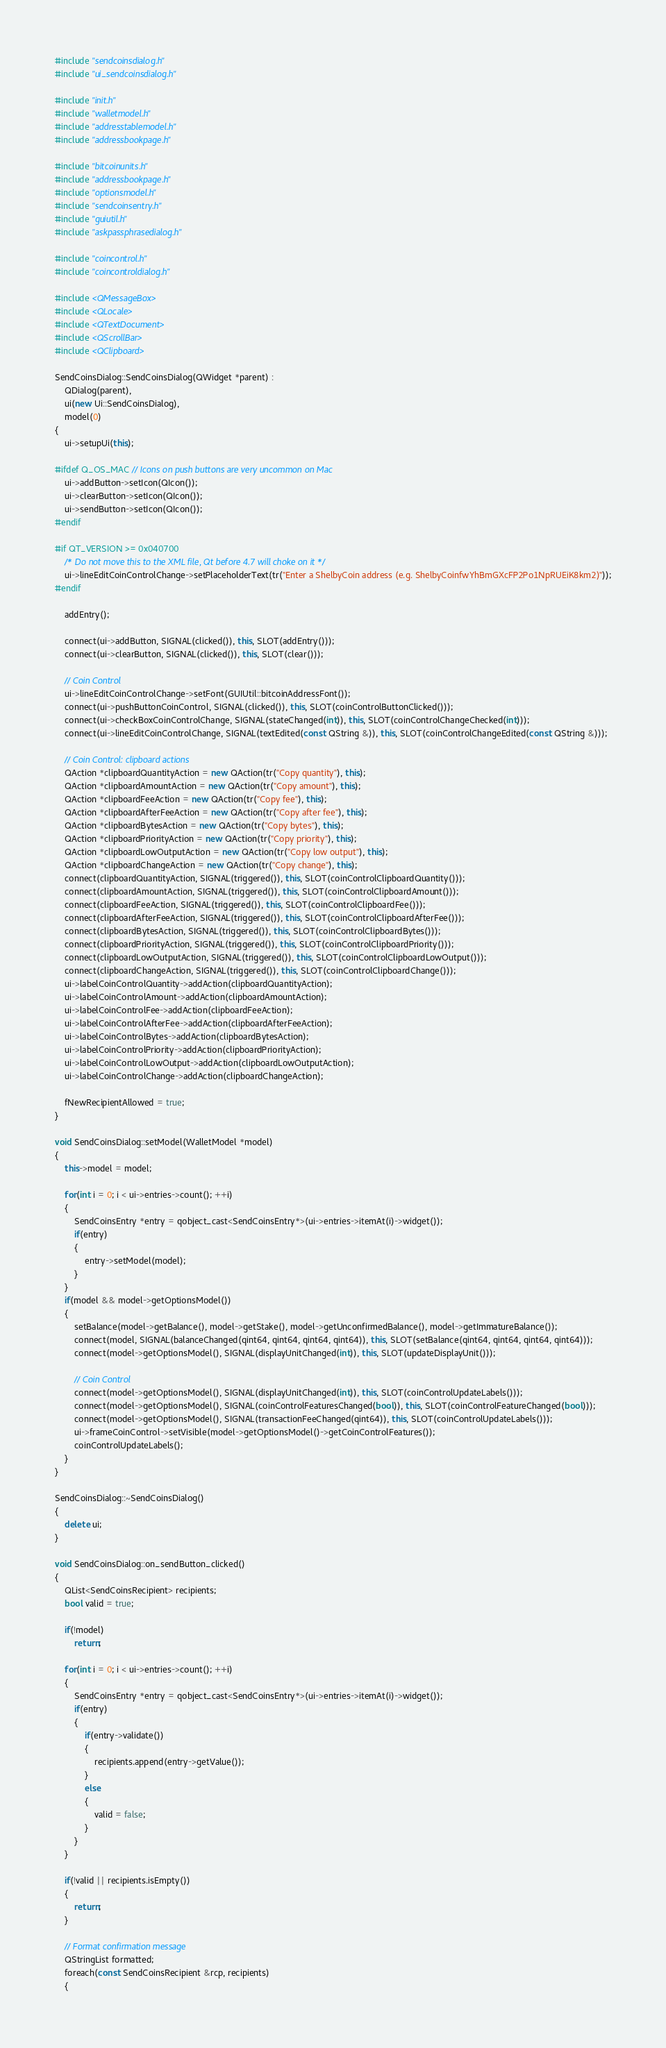Convert code to text. <code><loc_0><loc_0><loc_500><loc_500><_C++_>#include "sendcoinsdialog.h"
#include "ui_sendcoinsdialog.h"

#include "init.h"
#include "walletmodel.h"
#include "addresstablemodel.h"
#include "addressbookpage.h"

#include "bitcoinunits.h"
#include "addressbookpage.h"
#include "optionsmodel.h"
#include "sendcoinsentry.h"
#include "guiutil.h"
#include "askpassphrasedialog.h"

#include "coincontrol.h"
#include "coincontroldialog.h"

#include <QMessageBox>
#include <QLocale>
#include <QTextDocument>
#include <QScrollBar>
#include <QClipboard>

SendCoinsDialog::SendCoinsDialog(QWidget *parent) :
    QDialog(parent),
    ui(new Ui::SendCoinsDialog),
    model(0)
{
    ui->setupUi(this);

#ifdef Q_OS_MAC // Icons on push buttons are very uncommon on Mac
    ui->addButton->setIcon(QIcon());
    ui->clearButton->setIcon(QIcon());
    ui->sendButton->setIcon(QIcon());
#endif

#if QT_VERSION >= 0x040700
    /* Do not move this to the XML file, Qt before 4.7 will choke on it */
    ui->lineEditCoinControlChange->setPlaceholderText(tr("Enter a ShelbyCoin address (e.g. ShelbyCoinfwYhBmGXcFP2Po1NpRUEiK8km2)"));
#endif

    addEntry();

    connect(ui->addButton, SIGNAL(clicked()), this, SLOT(addEntry()));
    connect(ui->clearButton, SIGNAL(clicked()), this, SLOT(clear()));

    // Coin Control
    ui->lineEditCoinControlChange->setFont(GUIUtil::bitcoinAddressFont());
    connect(ui->pushButtonCoinControl, SIGNAL(clicked()), this, SLOT(coinControlButtonClicked()));
    connect(ui->checkBoxCoinControlChange, SIGNAL(stateChanged(int)), this, SLOT(coinControlChangeChecked(int)));
    connect(ui->lineEditCoinControlChange, SIGNAL(textEdited(const QString &)), this, SLOT(coinControlChangeEdited(const QString &)));

    // Coin Control: clipboard actions
    QAction *clipboardQuantityAction = new QAction(tr("Copy quantity"), this);
    QAction *clipboardAmountAction = new QAction(tr("Copy amount"), this);
    QAction *clipboardFeeAction = new QAction(tr("Copy fee"), this);
    QAction *clipboardAfterFeeAction = new QAction(tr("Copy after fee"), this);
    QAction *clipboardBytesAction = new QAction(tr("Copy bytes"), this);
    QAction *clipboardPriorityAction = new QAction(tr("Copy priority"), this);
    QAction *clipboardLowOutputAction = new QAction(tr("Copy low output"), this);
    QAction *clipboardChangeAction = new QAction(tr("Copy change"), this);
    connect(clipboardQuantityAction, SIGNAL(triggered()), this, SLOT(coinControlClipboardQuantity()));
    connect(clipboardAmountAction, SIGNAL(triggered()), this, SLOT(coinControlClipboardAmount()));
    connect(clipboardFeeAction, SIGNAL(triggered()), this, SLOT(coinControlClipboardFee()));
    connect(clipboardAfterFeeAction, SIGNAL(triggered()), this, SLOT(coinControlClipboardAfterFee()));
    connect(clipboardBytesAction, SIGNAL(triggered()), this, SLOT(coinControlClipboardBytes()));
    connect(clipboardPriorityAction, SIGNAL(triggered()), this, SLOT(coinControlClipboardPriority()));
    connect(clipboardLowOutputAction, SIGNAL(triggered()), this, SLOT(coinControlClipboardLowOutput()));
    connect(clipboardChangeAction, SIGNAL(triggered()), this, SLOT(coinControlClipboardChange()));
    ui->labelCoinControlQuantity->addAction(clipboardQuantityAction);
    ui->labelCoinControlAmount->addAction(clipboardAmountAction);
    ui->labelCoinControlFee->addAction(clipboardFeeAction);
    ui->labelCoinControlAfterFee->addAction(clipboardAfterFeeAction);
    ui->labelCoinControlBytes->addAction(clipboardBytesAction);
    ui->labelCoinControlPriority->addAction(clipboardPriorityAction);
    ui->labelCoinControlLowOutput->addAction(clipboardLowOutputAction);
    ui->labelCoinControlChange->addAction(clipboardChangeAction);

    fNewRecipientAllowed = true;
}

void SendCoinsDialog::setModel(WalletModel *model)
{
    this->model = model;

    for(int i = 0; i < ui->entries->count(); ++i)
    {
        SendCoinsEntry *entry = qobject_cast<SendCoinsEntry*>(ui->entries->itemAt(i)->widget());
        if(entry)
        {
            entry->setModel(model);
        }
    }
    if(model && model->getOptionsModel())
    {
        setBalance(model->getBalance(), model->getStake(), model->getUnconfirmedBalance(), model->getImmatureBalance());
        connect(model, SIGNAL(balanceChanged(qint64, qint64, qint64, qint64)), this, SLOT(setBalance(qint64, qint64, qint64, qint64)));
        connect(model->getOptionsModel(), SIGNAL(displayUnitChanged(int)), this, SLOT(updateDisplayUnit()));

        // Coin Control
        connect(model->getOptionsModel(), SIGNAL(displayUnitChanged(int)), this, SLOT(coinControlUpdateLabels()));
        connect(model->getOptionsModel(), SIGNAL(coinControlFeaturesChanged(bool)), this, SLOT(coinControlFeatureChanged(bool)));
        connect(model->getOptionsModel(), SIGNAL(transactionFeeChanged(qint64)), this, SLOT(coinControlUpdateLabels()));
        ui->frameCoinControl->setVisible(model->getOptionsModel()->getCoinControlFeatures());
        coinControlUpdateLabels();
    }
}

SendCoinsDialog::~SendCoinsDialog()
{
    delete ui;
}

void SendCoinsDialog::on_sendButton_clicked()
{
    QList<SendCoinsRecipient> recipients;
    bool valid = true;

    if(!model)
        return;

    for(int i = 0; i < ui->entries->count(); ++i)
    {
        SendCoinsEntry *entry = qobject_cast<SendCoinsEntry*>(ui->entries->itemAt(i)->widget());
        if(entry)
        {
            if(entry->validate())
            {
                recipients.append(entry->getValue());
            }
            else
            {
                valid = false;
            }
        }
    }

    if(!valid || recipients.isEmpty())
    {
        return;
    }

    // Format confirmation message
    QStringList formatted;
    foreach(const SendCoinsRecipient &rcp, recipients)
    {</code> 